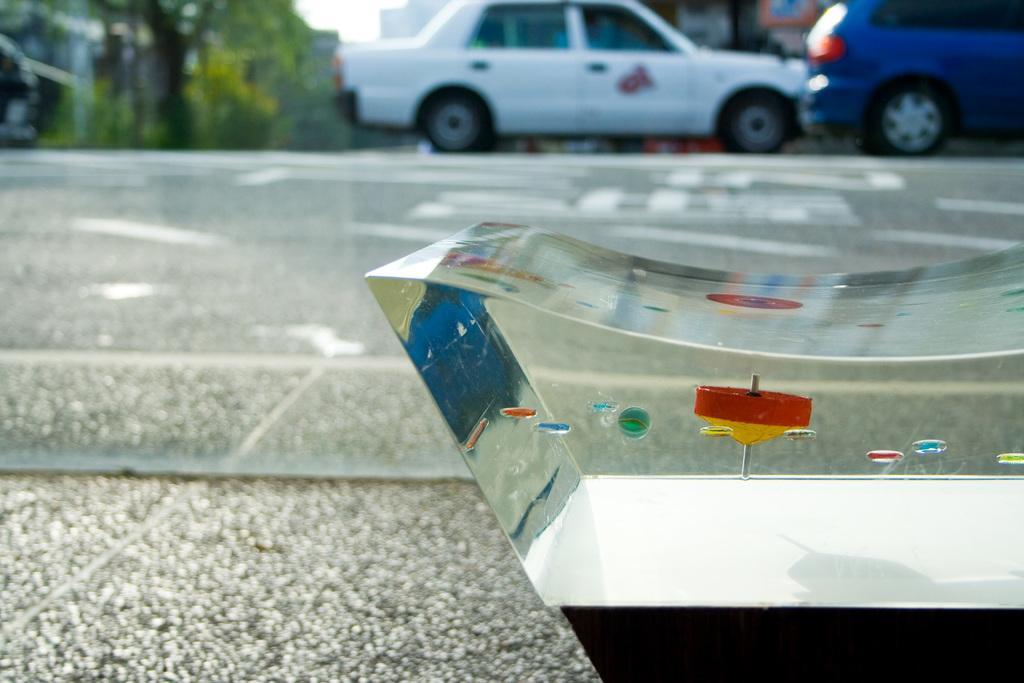Please provide a concise description of this image. In the center of the image we can see a glass on the road. In the background there are vehicles, buildings, trees and sky. 